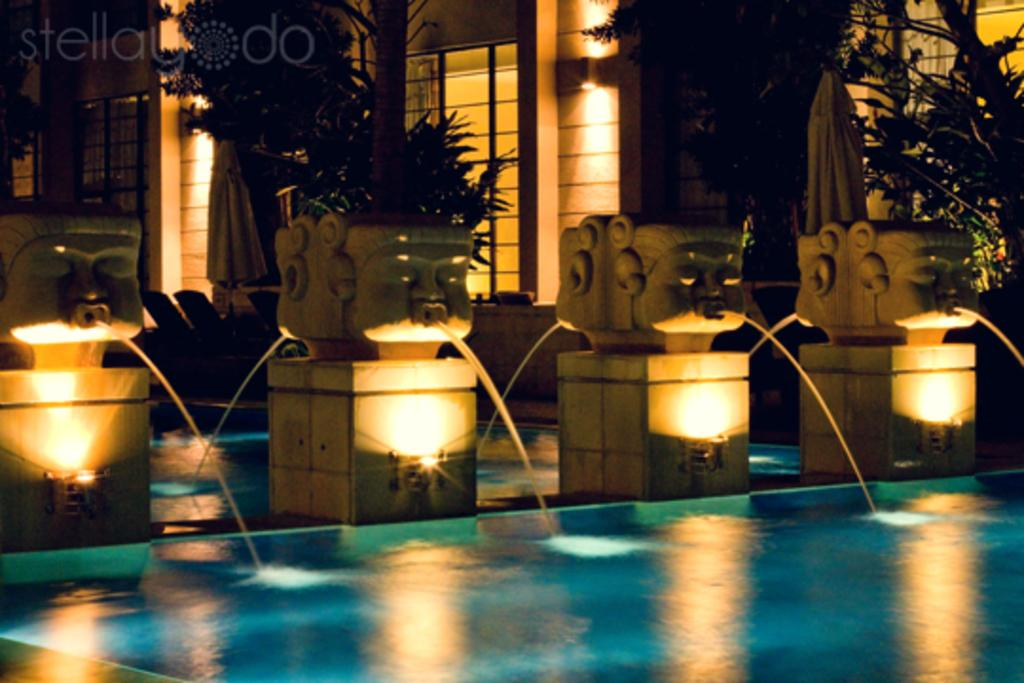What is the main subject in the center of the image? There are sculptures in the center of the image. What can be seen at the bottom of the image? There is a swimming pool at the bottom of the image. What type of vegetation is present in the image? There are plants in the image. What type of building is visible in the image? There is a house in the image. What architectural features can be seen in the house? There are windows and curtains in the image. What type of lighting is present in the image? There are lights in the image. Where is the kettle located in the image? There is no kettle present in the image. What type of berry is growing on the plants in the image? There is no mention of berries in the image; only plants are mentioned. 